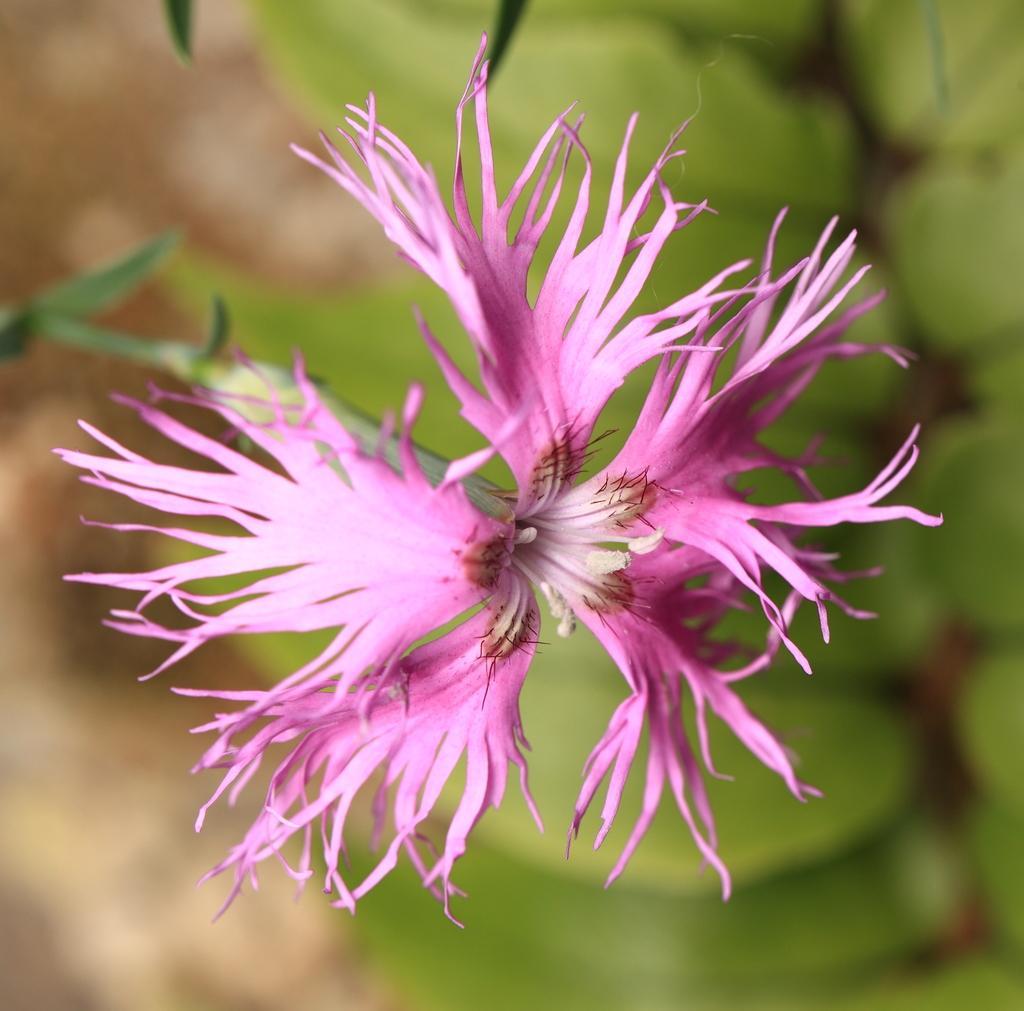Describe this image in one or two sentences. This picture contains flower which is pink in color. In the background, it is green in color and it is blurred in the background. 